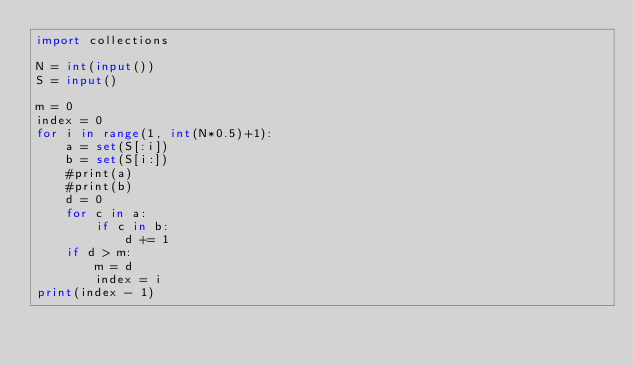<code> <loc_0><loc_0><loc_500><loc_500><_Python_>import collections

N = int(input())
S = input()

m = 0
index = 0
for i in range(1, int(N*0.5)+1):
    a = set(S[:i])
    b = set(S[i:])
    #print(a)
    #print(b)
    d = 0
    for c in a:
        if c in b:
            d += 1
    if d > m:
        m = d
        index = i
print(index - 1)</code> 